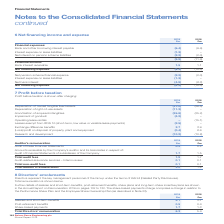According to Spirax Sarco Engineering Plc's financial document, What details are shown in the Annual Report on Remuneration 2019? Further details of salaries and short-term benefits, post-retirement benefits, share plans and long-term share incentive plans. The document states: "Further details of salaries and short-term benefits, post-retirement benefits, share plans and long-term share incentive plans are shown in the Annual..." Also, What do the share-based payments charge comprise? a charge in relation to the Performance Share Plan and the Employee Share Ownership Plan (as described in Note 23).. The document states: "to 132. The share-based payments charge comprises a charge in relation to the Performance Share Plan and the Employee Share Ownership Plan (as describ..." Also, What are the components considered in the calculation of the Total Directors' remuneration? The document contains multiple relevant values: Salaries and short-term benefits, Post-retirement benefits, Share-based payments. From the document: "2018 £m Salaries and short-term benefits 4.1 3.7 Post-retirement benefits 0.5 0.4 Share-based payments 1.7 1.3 Total Directors' remuneration 2018 £m S..." Additionally, In which year was the share-based payments larger? According to the financial document, 2019. The relevant text states: "Spirax-Sarco Engineering plc Annual Report 2019..." Also, can you calculate: What was the change in the total directors' remuneration in 2019 from 2018? Based on the calculation: 6.3-5.4, the result is 0.9 (in millions). This is based on the information: "ayments 1.7 1.3 Total Directors' remuneration 6.3 5.4 ed payments 1.7 1.3 Total Directors' remuneration 6.3 5.4..." The key data points involved are: 5.4, 6.3. Also, can you calculate: What was the percentage change in the total directors' remuneration in 2019 from 2018? To answer this question, I need to perform calculations using the financial data. The calculation is: (6.3-5.4)/5.4, which equals 16.67 (percentage). This is based on the information: "ayments 1.7 1.3 Total Directors' remuneration 6.3 5.4 ed payments 1.7 1.3 Total Directors' remuneration 6.3 5.4..." The key data points involved are: 5.4, 6.3. 